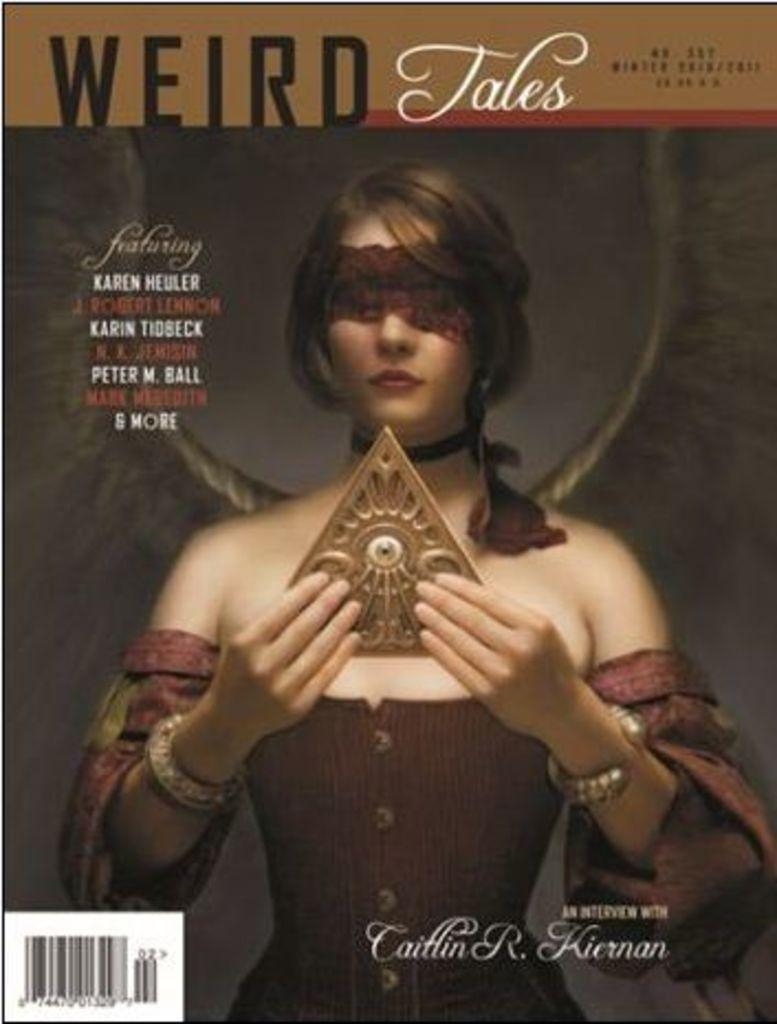Provide a one-sentence caption for the provided image. a copy of a WEIRD Tales magazine that says it has an interview with Caitlin R. Kiernan, & it pictures a woman on the cover. 